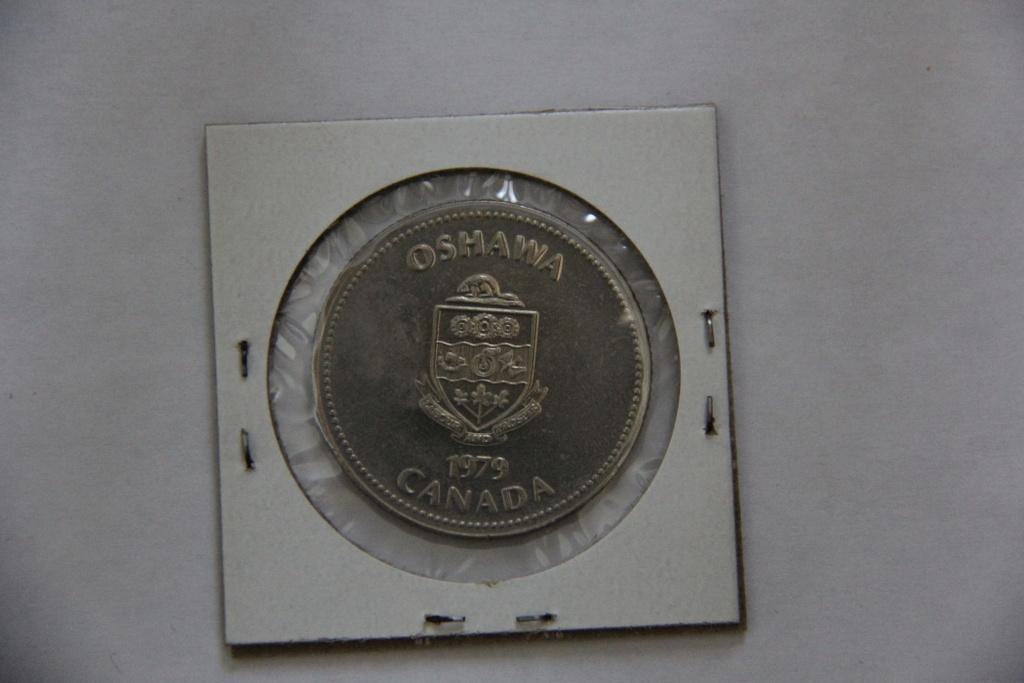<image>
Relay a brief, clear account of the picture shown. a coin that says oshawa and 1979 canada 